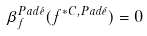Convert formula to latex. <formula><loc_0><loc_0><loc_500><loc_500>\beta _ { f } ^ { P a d \acute { e } } ( f ^ { * C , P a d \acute { e } } ) = 0</formula> 